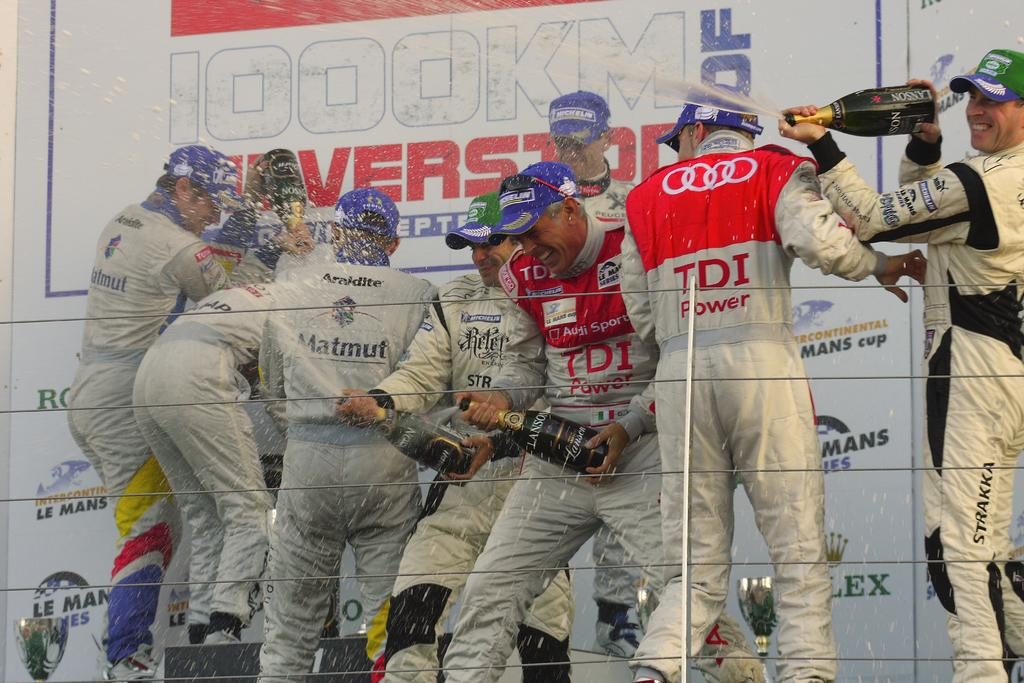<image>
Write a terse but informative summary of the picture. Olympic team, sponsored by TDI and Matmut, celebrating 